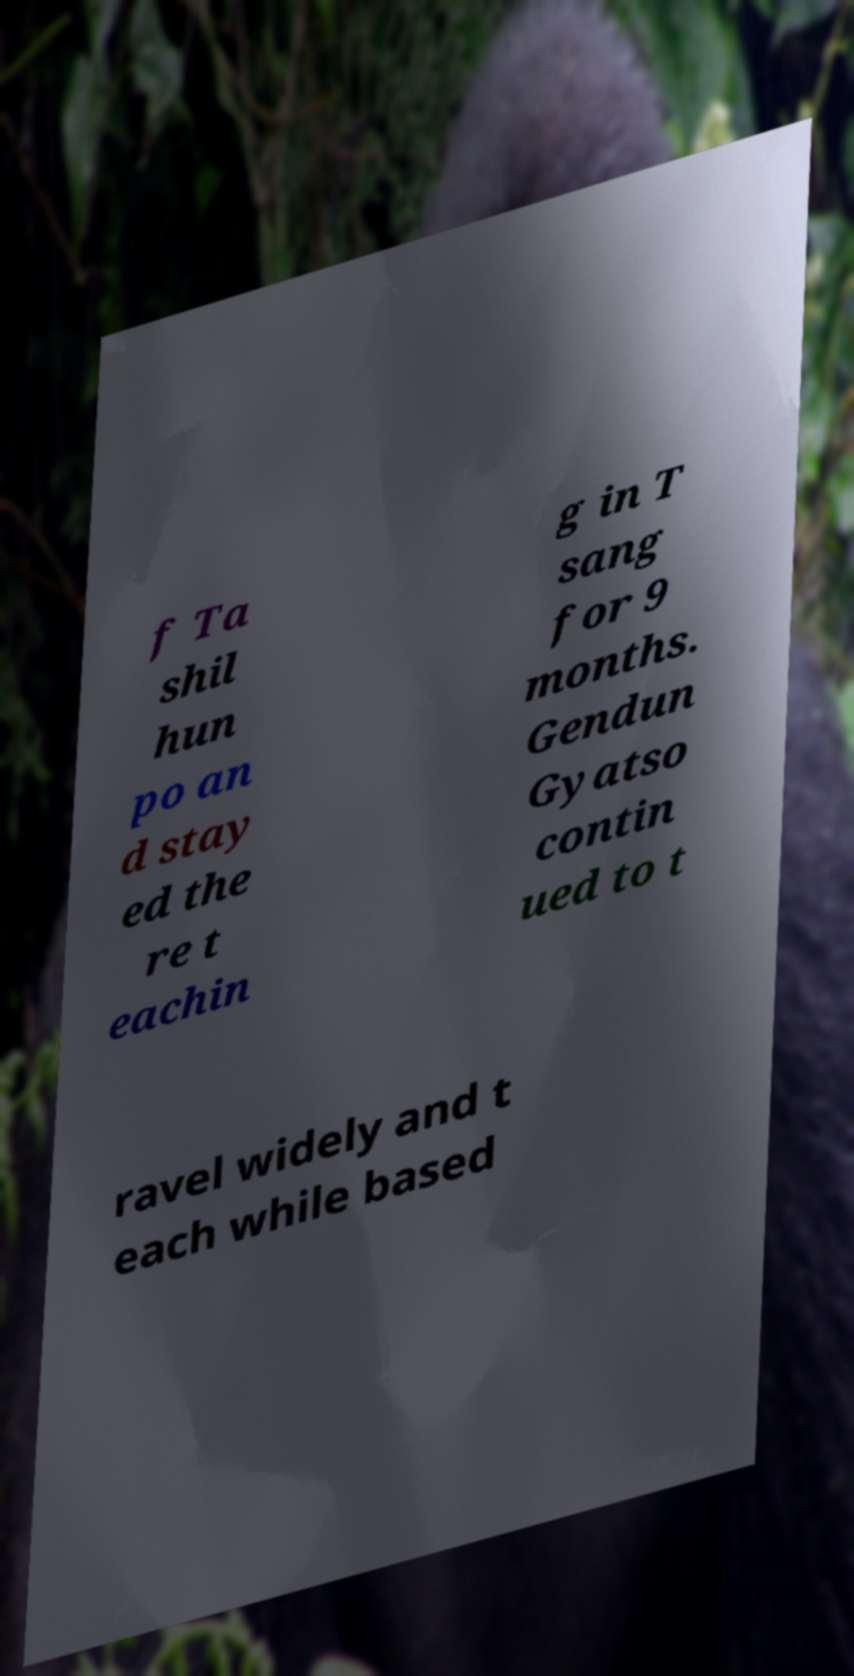Please identify and transcribe the text found in this image. f Ta shil hun po an d stay ed the re t eachin g in T sang for 9 months. Gendun Gyatso contin ued to t ravel widely and t each while based 